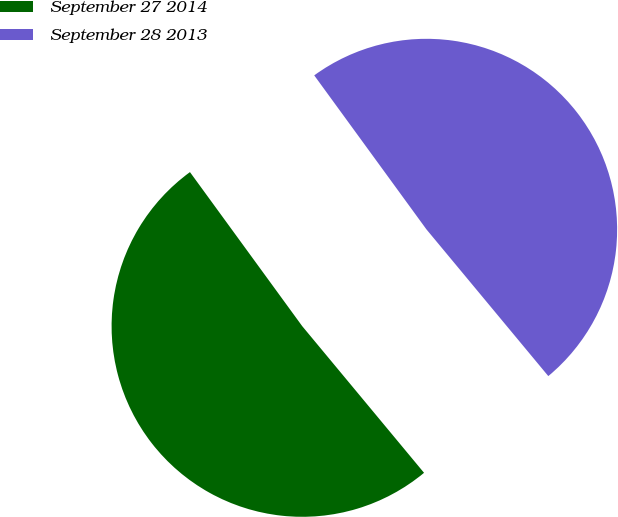Convert chart. <chart><loc_0><loc_0><loc_500><loc_500><pie_chart><fcel>September 27 2014<fcel>September 28 2013<nl><fcel>51.01%<fcel>48.99%<nl></chart> 